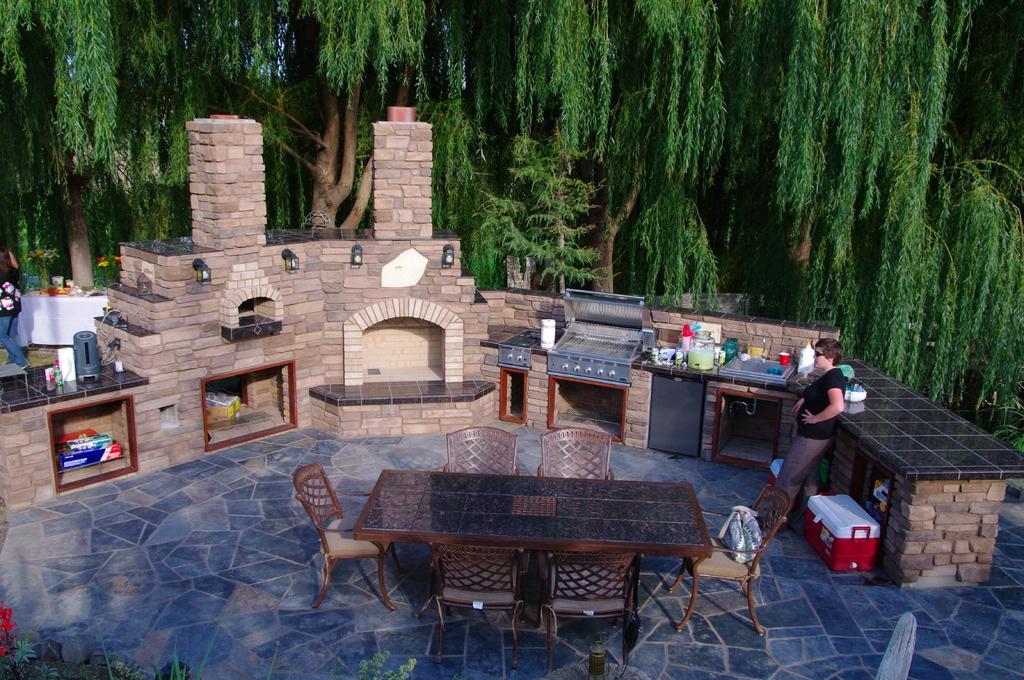Please provide a concise description of this image. In this picture I can see there is a woman standing here and there is a kitchen here. There are tables and chairs, plants and in the backdrop I can see there are trees. 